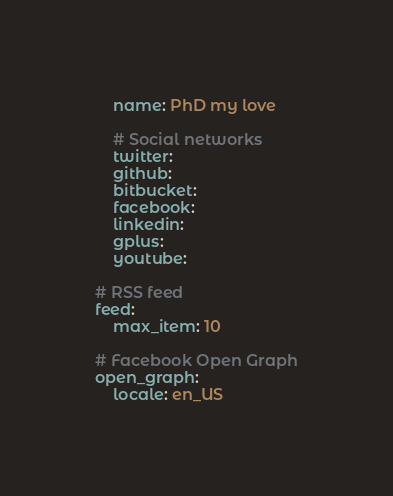<code> <loc_0><loc_0><loc_500><loc_500><_YAML_>    name: PhD my love

    # Social networks
    twitter:
    github:
    bitbucket:
    facebook:
    linkedin:
    gplus:
    youtube:

# RSS feed
feed:
    max_item: 10

# Facebook Open Graph
open_graph:
    locale: en_US
</code> 